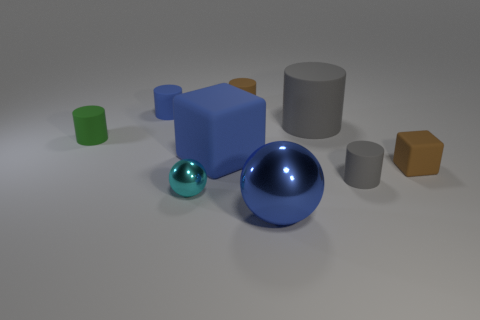Subtract 1 cylinders. How many cylinders are left? 4 Subtract all small brown matte cylinders. How many cylinders are left? 4 Subtract all cyan cylinders. Subtract all cyan blocks. How many cylinders are left? 5 Add 1 yellow cylinders. How many objects exist? 10 Subtract all cubes. How many objects are left? 7 Subtract all small brown cubes. Subtract all gray things. How many objects are left? 6 Add 6 cyan shiny balls. How many cyan shiny balls are left? 7 Add 4 rubber cubes. How many rubber cubes exist? 6 Subtract 1 blue cubes. How many objects are left? 8 